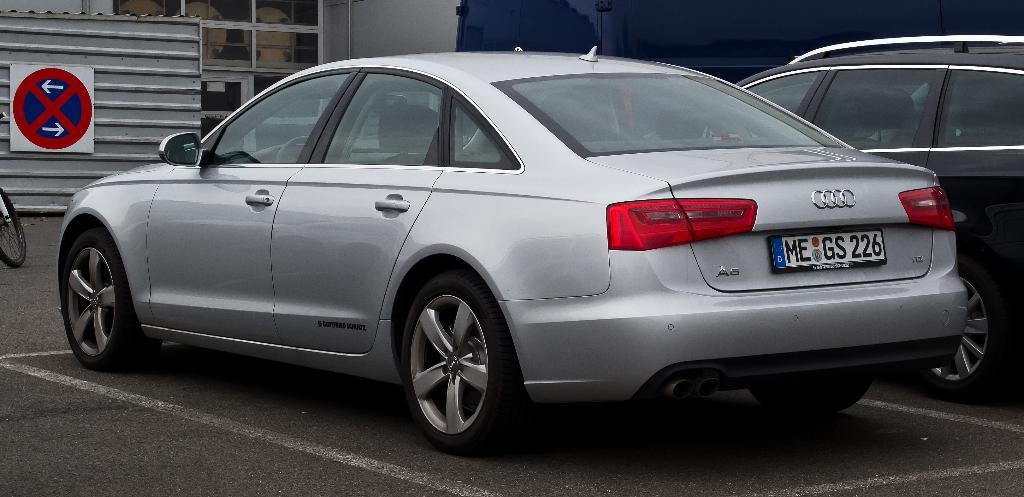<image>
Describe the image concisely. Audi vehicle that has a license plate saying Me GS 226, and a sign that says no left or right turn. 